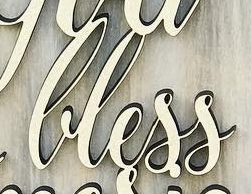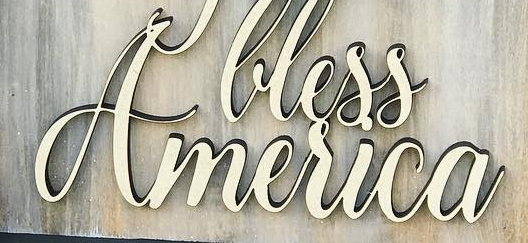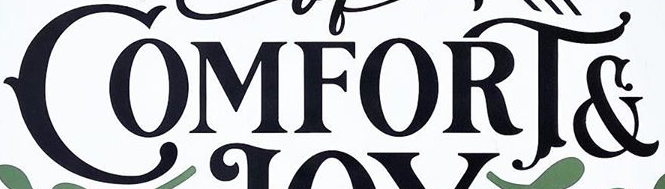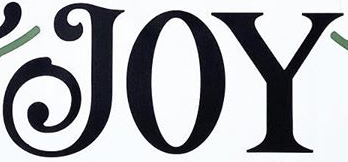What words are shown in these images in order, separated by a semicolon? lless; America; COMFORT&; JOY 